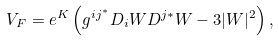Convert formula to latex. <formula><loc_0><loc_0><loc_500><loc_500>V _ { F } = e ^ { K } \left ( g ^ { i j ^ { * } } D _ { i } W D ^ { j * } W - 3 | W | ^ { 2 } \right ) ,</formula> 